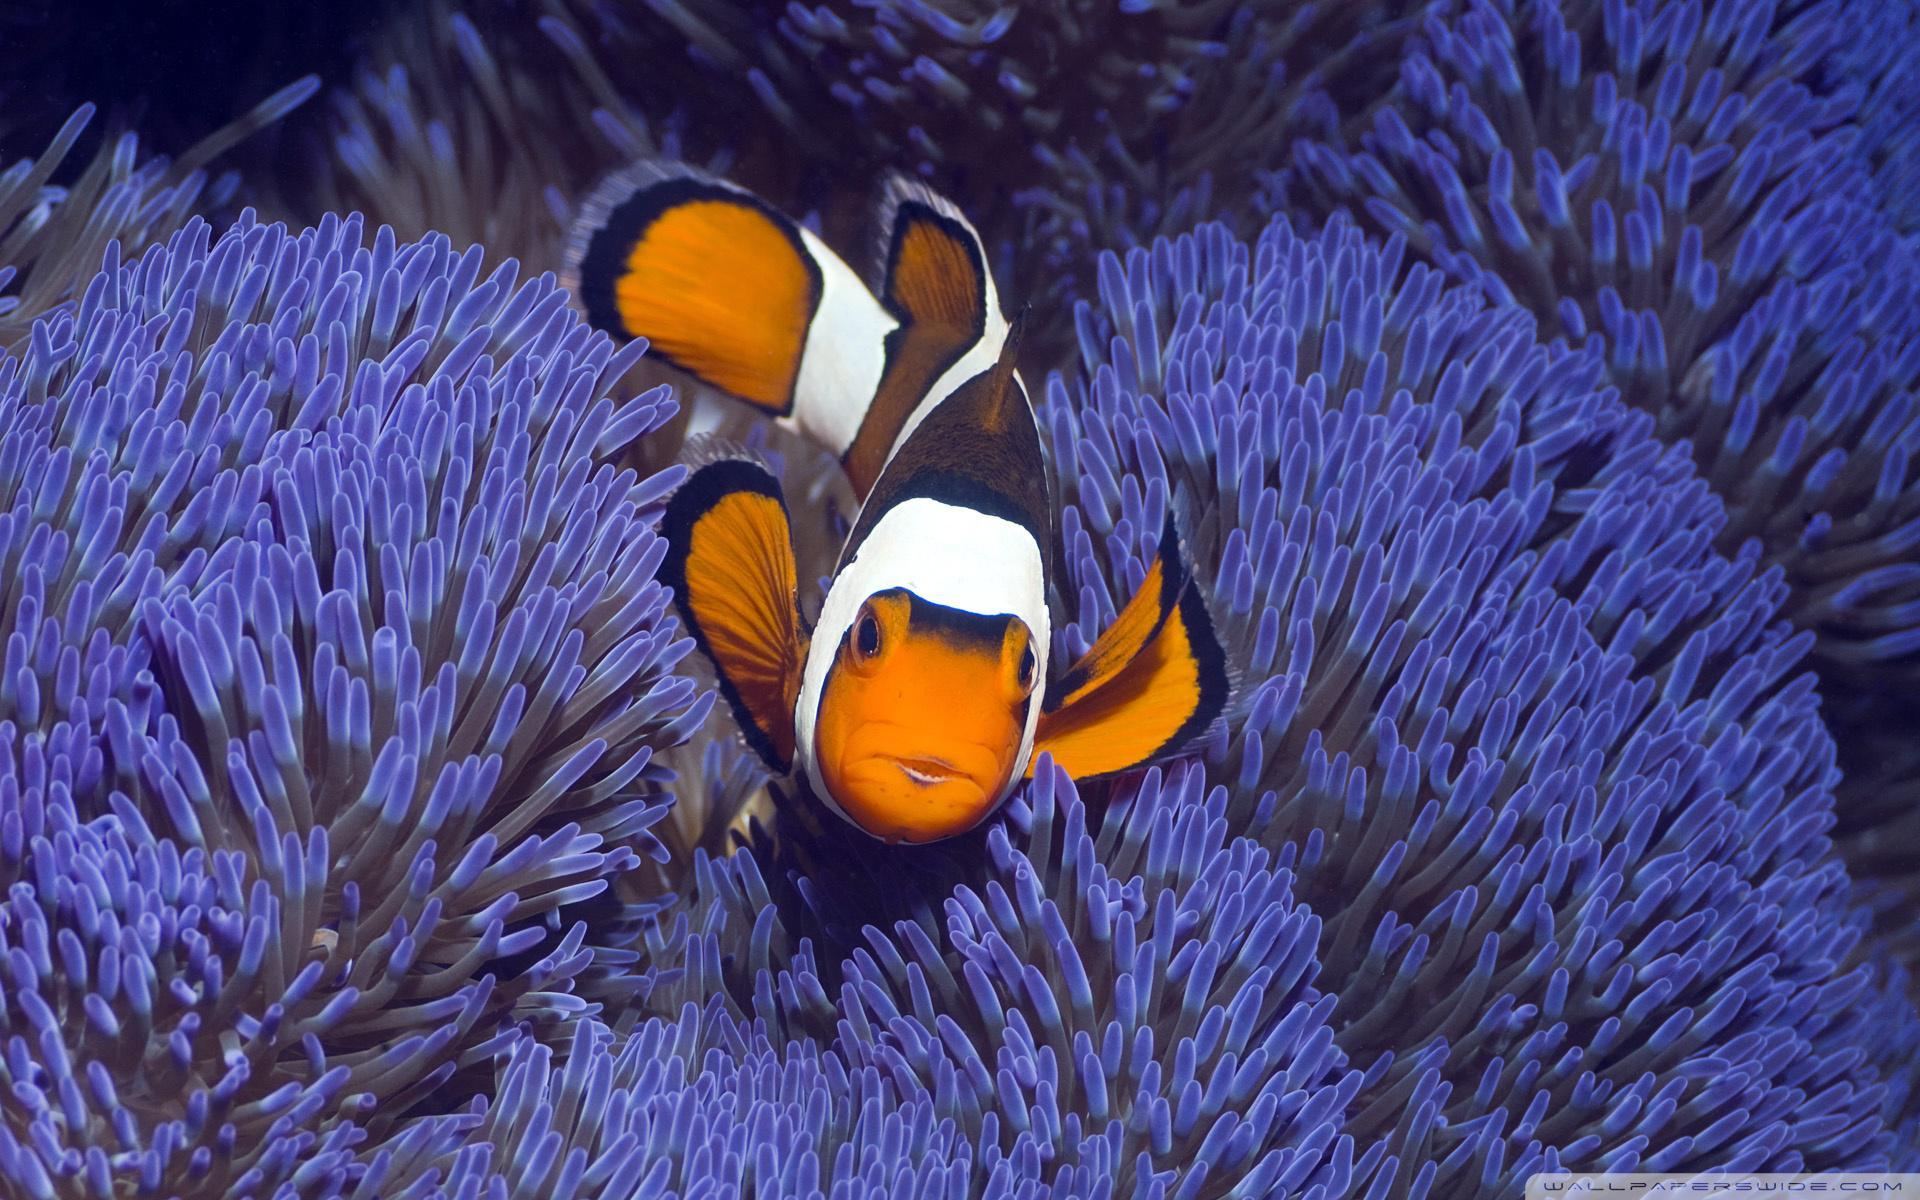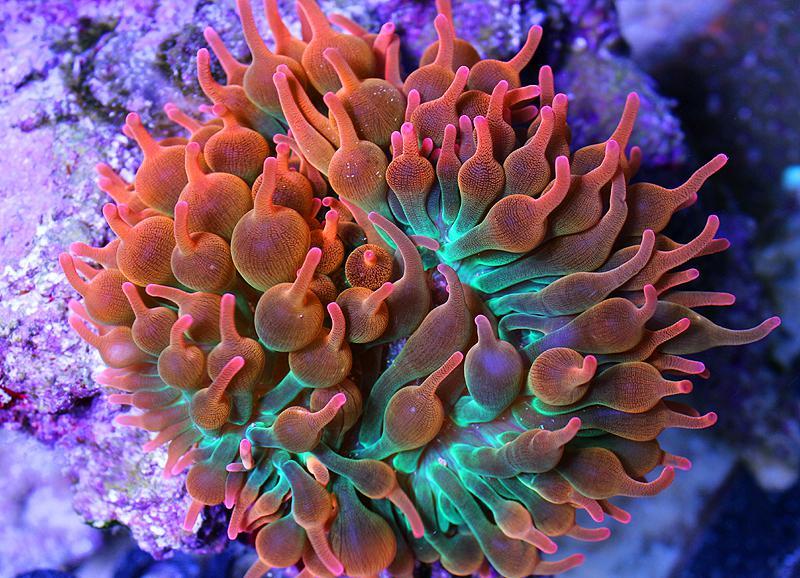The first image is the image on the left, the second image is the image on the right. Examine the images to the left and right. Is the description "There are orange, black and white stripe section on a single cloud fish that is in the arms of the corral." accurate? Answer yes or no. Yes. The first image is the image on the left, the second image is the image on the right. Considering the images on both sides, is "The left image shows one starfish swimming above anemone tendrils, and the right image includes a red-orange anemone." valid? Answer yes or no. Yes. 